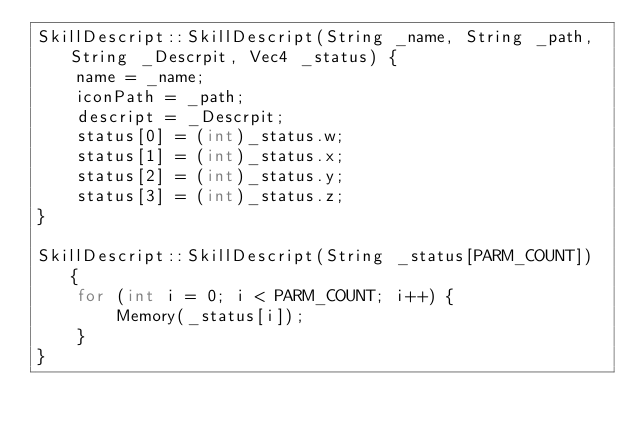Convert code to text. <code><loc_0><loc_0><loc_500><loc_500><_C++_>SkillDescript::SkillDescript(String _name, String _path, String _Descrpit, Vec4 _status) {
	name = _name;
	iconPath = _path;
	descript = _Descrpit;
	status[0] = (int)_status.w;
	status[1] = (int)_status.x;
	status[2] = (int)_status.y;
	status[3] = (int)_status.z;
}

SkillDescript::SkillDescript(String _status[PARM_COUNT]) {
	for (int i = 0; i < PARM_COUNT; i++) {
		Memory(_status[i]);
	}
}
</code> 